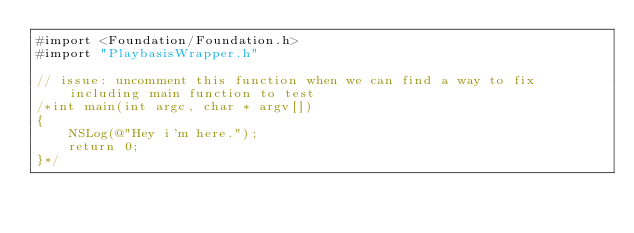<code> <loc_0><loc_0><loc_500><loc_500><_ObjectiveC_>#import <Foundation/Foundation.h>
#import "PlaybasisWrapper.h"

// issue: uncomment this function when we can find a way to fix including main function to test
/*int main(int argc, char * argv[])
{
	NSLog(@"Hey i'm here.");
	return 0;
}*/</code> 